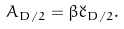<formula> <loc_0><loc_0><loc_500><loc_500>A _ { D / 2 } = \beta \breve { c } _ { D / 2 } .</formula> 